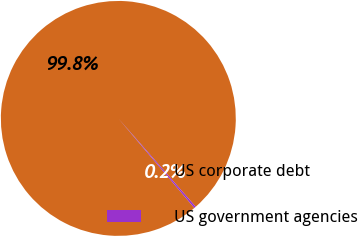<chart> <loc_0><loc_0><loc_500><loc_500><pie_chart><fcel>US corporate debt<fcel>US government agencies<nl><fcel>99.75%<fcel>0.25%<nl></chart> 